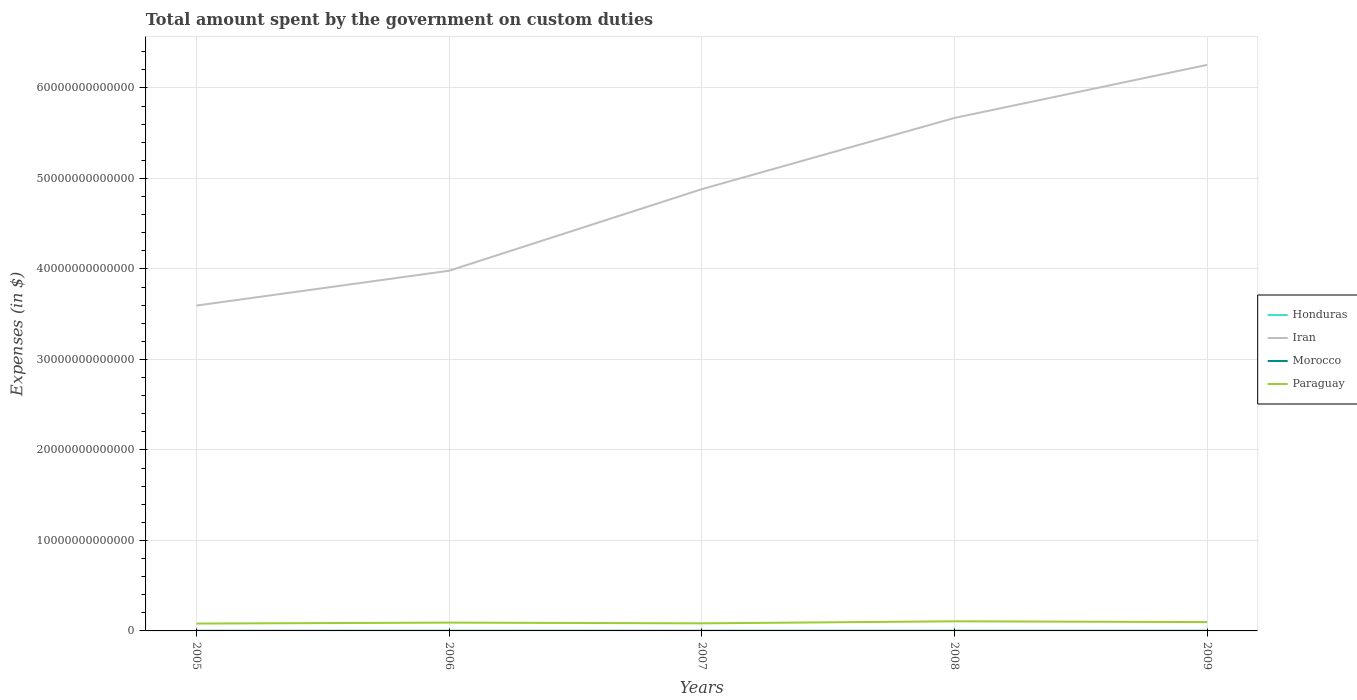Does the line corresponding to Iran intersect with the line corresponding to Morocco?
Your answer should be very brief. No. Is the number of lines equal to the number of legend labels?
Offer a terse response. Yes. Across all years, what is the maximum amount spent on custom duties by the government in Iran?
Provide a short and direct response. 3.60e+13. What is the total amount spent on custom duties by the government in Paraguay in the graph?
Make the answer very short. -1.40e+11. What is the difference between the highest and the second highest amount spent on custom duties by the government in Paraguay?
Your answer should be very brief. 2.49e+11. Is the amount spent on custom duties by the government in Iran strictly greater than the amount spent on custom duties by the government in Honduras over the years?
Your answer should be very brief. No. How many lines are there?
Offer a terse response. 4. What is the difference between two consecutive major ticks on the Y-axis?
Keep it short and to the point. 1.00e+13. Are the values on the major ticks of Y-axis written in scientific E-notation?
Offer a very short reply. No. Where does the legend appear in the graph?
Your answer should be very brief. Center right. How many legend labels are there?
Keep it short and to the point. 4. How are the legend labels stacked?
Give a very brief answer. Vertical. What is the title of the graph?
Give a very brief answer. Total amount spent by the government on custom duties. Does "Cyprus" appear as one of the legend labels in the graph?
Make the answer very short. No. What is the label or title of the Y-axis?
Your answer should be very brief. Expenses (in $). What is the Expenses (in $) in Honduras in 2005?
Ensure brevity in your answer.  2.18e+09. What is the Expenses (in $) of Iran in 2005?
Your answer should be very brief. 3.60e+13. What is the Expenses (in $) of Morocco in 2005?
Offer a terse response. 1.24e+1. What is the Expenses (in $) in Paraguay in 2005?
Your response must be concise. 8.13e+11. What is the Expenses (in $) in Honduras in 2006?
Keep it short and to the point. 2.35e+09. What is the Expenses (in $) in Iran in 2006?
Offer a terse response. 3.98e+13. What is the Expenses (in $) in Morocco in 2006?
Provide a short and direct response. 1.23e+1. What is the Expenses (in $) in Paraguay in 2006?
Ensure brevity in your answer.  9.18e+11. What is the Expenses (in $) of Honduras in 2007?
Make the answer very short. 2.88e+09. What is the Expenses (in $) in Iran in 2007?
Offer a terse response. 4.88e+13. What is the Expenses (in $) in Morocco in 2007?
Give a very brief answer. 1.34e+1. What is the Expenses (in $) of Paraguay in 2007?
Provide a succinct answer. 8.38e+11. What is the Expenses (in $) of Honduras in 2008?
Make the answer very short. 2.98e+09. What is the Expenses (in $) of Iran in 2008?
Offer a terse response. 5.67e+13. What is the Expenses (in $) of Morocco in 2008?
Give a very brief answer. 1.37e+1. What is the Expenses (in $) of Paraguay in 2008?
Keep it short and to the point. 1.06e+12. What is the Expenses (in $) of Honduras in 2009?
Keep it short and to the point. 2.07e+09. What is the Expenses (in $) in Iran in 2009?
Your answer should be very brief. 6.26e+13. What is the Expenses (in $) in Morocco in 2009?
Offer a terse response. 1.18e+1. What is the Expenses (in $) of Paraguay in 2009?
Your answer should be compact. 9.77e+11. Across all years, what is the maximum Expenses (in $) in Honduras?
Your answer should be compact. 2.98e+09. Across all years, what is the maximum Expenses (in $) in Iran?
Give a very brief answer. 6.26e+13. Across all years, what is the maximum Expenses (in $) of Morocco?
Keep it short and to the point. 1.37e+1. Across all years, what is the maximum Expenses (in $) in Paraguay?
Your answer should be very brief. 1.06e+12. Across all years, what is the minimum Expenses (in $) in Honduras?
Ensure brevity in your answer.  2.07e+09. Across all years, what is the minimum Expenses (in $) in Iran?
Provide a short and direct response. 3.60e+13. Across all years, what is the minimum Expenses (in $) in Morocco?
Your response must be concise. 1.18e+1. Across all years, what is the minimum Expenses (in $) of Paraguay?
Offer a very short reply. 8.13e+11. What is the total Expenses (in $) of Honduras in the graph?
Keep it short and to the point. 1.25e+1. What is the total Expenses (in $) of Iran in the graph?
Provide a succinct answer. 2.44e+14. What is the total Expenses (in $) of Morocco in the graph?
Your answer should be very brief. 6.37e+1. What is the total Expenses (in $) in Paraguay in the graph?
Give a very brief answer. 4.61e+12. What is the difference between the Expenses (in $) of Honduras in 2005 and that in 2006?
Ensure brevity in your answer.  -1.74e+08. What is the difference between the Expenses (in $) in Iran in 2005 and that in 2006?
Your answer should be compact. -3.85e+12. What is the difference between the Expenses (in $) in Morocco in 2005 and that in 2006?
Keep it short and to the point. 6.50e+07. What is the difference between the Expenses (in $) in Paraguay in 2005 and that in 2006?
Give a very brief answer. -1.06e+11. What is the difference between the Expenses (in $) in Honduras in 2005 and that in 2007?
Ensure brevity in your answer.  -7.00e+08. What is the difference between the Expenses (in $) of Iran in 2005 and that in 2007?
Keep it short and to the point. -1.29e+13. What is the difference between the Expenses (in $) of Morocco in 2005 and that in 2007?
Offer a terse response. -1.01e+09. What is the difference between the Expenses (in $) in Paraguay in 2005 and that in 2007?
Your answer should be very brief. -2.49e+1. What is the difference between the Expenses (in $) in Honduras in 2005 and that in 2008?
Provide a succinct answer. -7.97e+08. What is the difference between the Expenses (in $) in Iran in 2005 and that in 2008?
Keep it short and to the point. -2.07e+13. What is the difference between the Expenses (in $) of Morocco in 2005 and that in 2008?
Your answer should be very brief. -1.30e+09. What is the difference between the Expenses (in $) in Paraguay in 2005 and that in 2008?
Provide a succinct answer. -2.49e+11. What is the difference between the Expenses (in $) of Honduras in 2005 and that in 2009?
Ensure brevity in your answer.  1.13e+08. What is the difference between the Expenses (in $) in Iran in 2005 and that in 2009?
Provide a succinct answer. -2.66e+13. What is the difference between the Expenses (in $) in Morocco in 2005 and that in 2009?
Your response must be concise. 5.79e+08. What is the difference between the Expenses (in $) of Paraguay in 2005 and that in 2009?
Ensure brevity in your answer.  -1.65e+11. What is the difference between the Expenses (in $) in Honduras in 2006 and that in 2007?
Keep it short and to the point. -5.26e+08. What is the difference between the Expenses (in $) of Iran in 2006 and that in 2007?
Provide a succinct answer. -9.01e+12. What is the difference between the Expenses (in $) in Morocco in 2006 and that in 2007?
Your answer should be very brief. -1.07e+09. What is the difference between the Expenses (in $) of Paraguay in 2006 and that in 2007?
Make the answer very short. 8.09e+1. What is the difference between the Expenses (in $) in Honduras in 2006 and that in 2008?
Provide a succinct answer. -6.22e+08. What is the difference between the Expenses (in $) in Iran in 2006 and that in 2008?
Offer a very short reply. -1.69e+13. What is the difference between the Expenses (in $) of Morocco in 2006 and that in 2008?
Your answer should be very brief. -1.36e+09. What is the difference between the Expenses (in $) of Paraguay in 2006 and that in 2008?
Provide a succinct answer. -1.43e+11. What is the difference between the Expenses (in $) of Honduras in 2006 and that in 2009?
Your response must be concise. 2.88e+08. What is the difference between the Expenses (in $) of Iran in 2006 and that in 2009?
Offer a very short reply. -2.27e+13. What is the difference between the Expenses (in $) of Morocco in 2006 and that in 2009?
Ensure brevity in your answer.  5.14e+08. What is the difference between the Expenses (in $) in Paraguay in 2006 and that in 2009?
Your answer should be very brief. -5.89e+1. What is the difference between the Expenses (in $) of Honduras in 2007 and that in 2008?
Make the answer very short. -9.62e+07. What is the difference between the Expenses (in $) in Iran in 2007 and that in 2008?
Keep it short and to the point. -7.87e+12. What is the difference between the Expenses (in $) of Morocco in 2007 and that in 2008?
Your answer should be very brief. -2.91e+08. What is the difference between the Expenses (in $) of Paraguay in 2007 and that in 2008?
Offer a terse response. -2.24e+11. What is the difference between the Expenses (in $) in Honduras in 2007 and that in 2009?
Keep it short and to the point. 8.14e+08. What is the difference between the Expenses (in $) in Iran in 2007 and that in 2009?
Provide a short and direct response. -1.37e+13. What is the difference between the Expenses (in $) in Morocco in 2007 and that in 2009?
Your answer should be very brief. 1.59e+09. What is the difference between the Expenses (in $) of Paraguay in 2007 and that in 2009?
Your answer should be compact. -1.40e+11. What is the difference between the Expenses (in $) in Honduras in 2008 and that in 2009?
Give a very brief answer. 9.10e+08. What is the difference between the Expenses (in $) in Iran in 2008 and that in 2009?
Offer a very short reply. -5.87e+12. What is the difference between the Expenses (in $) of Morocco in 2008 and that in 2009?
Give a very brief answer. 1.88e+09. What is the difference between the Expenses (in $) in Paraguay in 2008 and that in 2009?
Provide a short and direct response. 8.42e+1. What is the difference between the Expenses (in $) in Honduras in 2005 and the Expenses (in $) in Iran in 2006?
Your response must be concise. -3.98e+13. What is the difference between the Expenses (in $) of Honduras in 2005 and the Expenses (in $) of Morocco in 2006?
Your response must be concise. -1.02e+1. What is the difference between the Expenses (in $) of Honduras in 2005 and the Expenses (in $) of Paraguay in 2006?
Give a very brief answer. -9.16e+11. What is the difference between the Expenses (in $) of Iran in 2005 and the Expenses (in $) of Morocco in 2006?
Give a very brief answer. 3.59e+13. What is the difference between the Expenses (in $) in Iran in 2005 and the Expenses (in $) in Paraguay in 2006?
Make the answer very short. 3.50e+13. What is the difference between the Expenses (in $) of Morocco in 2005 and the Expenses (in $) of Paraguay in 2006?
Your answer should be very brief. -9.06e+11. What is the difference between the Expenses (in $) of Honduras in 2005 and the Expenses (in $) of Iran in 2007?
Give a very brief answer. -4.88e+13. What is the difference between the Expenses (in $) in Honduras in 2005 and the Expenses (in $) in Morocco in 2007?
Offer a very short reply. -1.12e+1. What is the difference between the Expenses (in $) in Honduras in 2005 and the Expenses (in $) in Paraguay in 2007?
Offer a terse response. -8.35e+11. What is the difference between the Expenses (in $) in Iran in 2005 and the Expenses (in $) in Morocco in 2007?
Offer a terse response. 3.59e+13. What is the difference between the Expenses (in $) of Iran in 2005 and the Expenses (in $) of Paraguay in 2007?
Ensure brevity in your answer.  3.51e+13. What is the difference between the Expenses (in $) in Morocco in 2005 and the Expenses (in $) in Paraguay in 2007?
Your answer should be compact. -8.25e+11. What is the difference between the Expenses (in $) in Honduras in 2005 and the Expenses (in $) in Iran in 2008?
Offer a very short reply. -5.67e+13. What is the difference between the Expenses (in $) in Honduras in 2005 and the Expenses (in $) in Morocco in 2008?
Provide a short and direct response. -1.15e+1. What is the difference between the Expenses (in $) in Honduras in 2005 and the Expenses (in $) in Paraguay in 2008?
Provide a succinct answer. -1.06e+12. What is the difference between the Expenses (in $) of Iran in 2005 and the Expenses (in $) of Morocco in 2008?
Offer a very short reply. 3.59e+13. What is the difference between the Expenses (in $) of Iran in 2005 and the Expenses (in $) of Paraguay in 2008?
Provide a succinct answer. 3.49e+13. What is the difference between the Expenses (in $) of Morocco in 2005 and the Expenses (in $) of Paraguay in 2008?
Ensure brevity in your answer.  -1.05e+12. What is the difference between the Expenses (in $) of Honduras in 2005 and the Expenses (in $) of Iran in 2009?
Your answer should be compact. -6.26e+13. What is the difference between the Expenses (in $) in Honduras in 2005 and the Expenses (in $) in Morocco in 2009?
Offer a very short reply. -9.65e+09. What is the difference between the Expenses (in $) of Honduras in 2005 and the Expenses (in $) of Paraguay in 2009?
Your response must be concise. -9.75e+11. What is the difference between the Expenses (in $) of Iran in 2005 and the Expenses (in $) of Morocco in 2009?
Offer a terse response. 3.59e+13. What is the difference between the Expenses (in $) in Iran in 2005 and the Expenses (in $) in Paraguay in 2009?
Offer a terse response. 3.50e+13. What is the difference between the Expenses (in $) of Morocco in 2005 and the Expenses (in $) of Paraguay in 2009?
Ensure brevity in your answer.  -9.65e+11. What is the difference between the Expenses (in $) in Honduras in 2006 and the Expenses (in $) in Iran in 2007?
Offer a terse response. -4.88e+13. What is the difference between the Expenses (in $) in Honduras in 2006 and the Expenses (in $) in Morocco in 2007?
Your answer should be compact. -1.11e+1. What is the difference between the Expenses (in $) in Honduras in 2006 and the Expenses (in $) in Paraguay in 2007?
Your answer should be compact. -8.35e+11. What is the difference between the Expenses (in $) in Iran in 2006 and the Expenses (in $) in Morocco in 2007?
Offer a terse response. 3.98e+13. What is the difference between the Expenses (in $) of Iran in 2006 and the Expenses (in $) of Paraguay in 2007?
Your answer should be compact. 3.90e+13. What is the difference between the Expenses (in $) of Morocco in 2006 and the Expenses (in $) of Paraguay in 2007?
Keep it short and to the point. -8.25e+11. What is the difference between the Expenses (in $) of Honduras in 2006 and the Expenses (in $) of Iran in 2008?
Offer a terse response. -5.67e+13. What is the difference between the Expenses (in $) in Honduras in 2006 and the Expenses (in $) in Morocco in 2008?
Your answer should be very brief. -1.14e+1. What is the difference between the Expenses (in $) in Honduras in 2006 and the Expenses (in $) in Paraguay in 2008?
Your response must be concise. -1.06e+12. What is the difference between the Expenses (in $) of Iran in 2006 and the Expenses (in $) of Morocco in 2008?
Ensure brevity in your answer.  3.98e+13. What is the difference between the Expenses (in $) of Iran in 2006 and the Expenses (in $) of Paraguay in 2008?
Your answer should be compact. 3.87e+13. What is the difference between the Expenses (in $) of Morocco in 2006 and the Expenses (in $) of Paraguay in 2008?
Offer a terse response. -1.05e+12. What is the difference between the Expenses (in $) of Honduras in 2006 and the Expenses (in $) of Iran in 2009?
Provide a succinct answer. -6.26e+13. What is the difference between the Expenses (in $) in Honduras in 2006 and the Expenses (in $) in Morocco in 2009?
Give a very brief answer. -9.48e+09. What is the difference between the Expenses (in $) of Honduras in 2006 and the Expenses (in $) of Paraguay in 2009?
Offer a very short reply. -9.75e+11. What is the difference between the Expenses (in $) of Iran in 2006 and the Expenses (in $) of Morocco in 2009?
Your response must be concise. 3.98e+13. What is the difference between the Expenses (in $) of Iran in 2006 and the Expenses (in $) of Paraguay in 2009?
Give a very brief answer. 3.88e+13. What is the difference between the Expenses (in $) of Morocco in 2006 and the Expenses (in $) of Paraguay in 2009?
Provide a succinct answer. -9.65e+11. What is the difference between the Expenses (in $) in Honduras in 2007 and the Expenses (in $) in Iran in 2008?
Keep it short and to the point. -5.67e+13. What is the difference between the Expenses (in $) in Honduras in 2007 and the Expenses (in $) in Morocco in 2008?
Give a very brief answer. -1.08e+1. What is the difference between the Expenses (in $) in Honduras in 2007 and the Expenses (in $) in Paraguay in 2008?
Offer a terse response. -1.06e+12. What is the difference between the Expenses (in $) of Iran in 2007 and the Expenses (in $) of Morocco in 2008?
Offer a very short reply. 4.88e+13. What is the difference between the Expenses (in $) of Iran in 2007 and the Expenses (in $) of Paraguay in 2008?
Your answer should be very brief. 4.78e+13. What is the difference between the Expenses (in $) in Morocco in 2007 and the Expenses (in $) in Paraguay in 2008?
Your answer should be very brief. -1.05e+12. What is the difference between the Expenses (in $) in Honduras in 2007 and the Expenses (in $) in Iran in 2009?
Ensure brevity in your answer.  -6.26e+13. What is the difference between the Expenses (in $) of Honduras in 2007 and the Expenses (in $) of Morocco in 2009?
Your response must be concise. -8.95e+09. What is the difference between the Expenses (in $) of Honduras in 2007 and the Expenses (in $) of Paraguay in 2009?
Your response must be concise. -9.75e+11. What is the difference between the Expenses (in $) in Iran in 2007 and the Expenses (in $) in Morocco in 2009?
Provide a succinct answer. 4.88e+13. What is the difference between the Expenses (in $) in Iran in 2007 and the Expenses (in $) in Paraguay in 2009?
Your response must be concise. 4.78e+13. What is the difference between the Expenses (in $) of Morocco in 2007 and the Expenses (in $) of Paraguay in 2009?
Your answer should be compact. -9.64e+11. What is the difference between the Expenses (in $) in Honduras in 2008 and the Expenses (in $) in Iran in 2009?
Ensure brevity in your answer.  -6.26e+13. What is the difference between the Expenses (in $) in Honduras in 2008 and the Expenses (in $) in Morocco in 2009?
Ensure brevity in your answer.  -8.85e+09. What is the difference between the Expenses (in $) in Honduras in 2008 and the Expenses (in $) in Paraguay in 2009?
Make the answer very short. -9.74e+11. What is the difference between the Expenses (in $) of Iran in 2008 and the Expenses (in $) of Morocco in 2009?
Provide a short and direct response. 5.67e+13. What is the difference between the Expenses (in $) in Iran in 2008 and the Expenses (in $) in Paraguay in 2009?
Provide a succinct answer. 5.57e+13. What is the difference between the Expenses (in $) of Morocco in 2008 and the Expenses (in $) of Paraguay in 2009?
Give a very brief answer. -9.64e+11. What is the average Expenses (in $) of Honduras per year?
Ensure brevity in your answer.  2.49e+09. What is the average Expenses (in $) of Iran per year?
Provide a short and direct response. 4.88e+13. What is the average Expenses (in $) in Morocco per year?
Your response must be concise. 1.27e+1. What is the average Expenses (in $) of Paraguay per year?
Give a very brief answer. 9.22e+11. In the year 2005, what is the difference between the Expenses (in $) of Honduras and Expenses (in $) of Iran?
Ensure brevity in your answer.  -3.60e+13. In the year 2005, what is the difference between the Expenses (in $) of Honduras and Expenses (in $) of Morocco?
Offer a very short reply. -1.02e+1. In the year 2005, what is the difference between the Expenses (in $) in Honduras and Expenses (in $) in Paraguay?
Ensure brevity in your answer.  -8.11e+11. In the year 2005, what is the difference between the Expenses (in $) in Iran and Expenses (in $) in Morocco?
Give a very brief answer. 3.59e+13. In the year 2005, what is the difference between the Expenses (in $) in Iran and Expenses (in $) in Paraguay?
Your response must be concise. 3.51e+13. In the year 2005, what is the difference between the Expenses (in $) of Morocco and Expenses (in $) of Paraguay?
Give a very brief answer. -8.00e+11. In the year 2006, what is the difference between the Expenses (in $) of Honduras and Expenses (in $) of Iran?
Offer a very short reply. -3.98e+13. In the year 2006, what is the difference between the Expenses (in $) in Honduras and Expenses (in $) in Morocco?
Offer a terse response. -9.99e+09. In the year 2006, what is the difference between the Expenses (in $) in Honduras and Expenses (in $) in Paraguay?
Keep it short and to the point. -9.16e+11. In the year 2006, what is the difference between the Expenses (in $) of Iran and Expenses (in $) of Morocco?
Provide a short and direct response. 3.98e+13. In the year 2006, what is the difference between the Expenses (in $) of Iran and Expenses (in $) of Paraguay?
Ensure brevity in your answer.  3.89e+13. In the year 2006, what is the difference between the Expenses (in $) in Morocco and Expenses (in $) in Paraguay?
Give a very brief answer. -9.06e+11. In the year 2007, what is the difference between the Expenses (in $) in Honduras and Expenses (in $) in Iran?
Keep it short and to the point. -4.88e+13. In the year 2007, what is the difference between the Expenses (in $) of Honduras and Expenses (in $) of Morocco?
Provide a succinct answer. -1.05e+1. In the year 2007, what is the difference between the Expenses (in $) of Honduras and Expenses (in $) of Paraguay?
Your answer should be compact. -8.35e+11. In the year 2007, what is the difference between the Expenses (in $) in Iran and Expenses (in $) in Morocco?
Provide a short and direct response. 4.88e+13. In the year 2007, what is the difference between the Expenses (in $) of Iran and Expenses (in $) of Paraguay?
Your answer should be compact. 4.80e+13. In the year 2007, what is the difference between the Expenses (in $) of Morocco and Expenses (in $) of Paraguay?
Give a very brief answer. -8.24e+11. In the year 2008, what is the difference between the Expenses (in $) in Honduras and Expenses (in $) in Iran?
Offer a terse response. -5.67e+13. In the year 2008, what is the difference between the Expenses (in $) in Honduras and Expenses (in $) in Morocco?
Offer a terse response. -1.07e+1. In the year 2008, what is the difference between the Expenses (in $) of Honduras and Expenses (in $) of Paraguay?
Provide a short and direct response. -1.06e+12. In the year 2008, what is the difference between the Expenses (in $) in Iran and Expenses (in $) in Morocco?
Provide a succinct answer. 5.67e+13. In the year 2008, what is the difference between the Expenses (in $) of Iran and Expenses (in $) of Paraguay?
Offer a very short reply. 5.56e+13. In the year 2008, what is the difference between the Expenses (in $) in Morocco and Expenses (in $) in Paraguay?
Provide a succinct answer. -1.05e+12. In the year 2009, what is the difference between the Expenses (in $) in Honduras and Expenses (in $) in Iran?
Offer a terse response. -6.26e+13. In the year 2009, what is the difference between the Expenses (in $) in Honduras and Expenses (in $) in Morocco?
Give a very brief answer. -9.76e+09. In the year 2009, what is the difference between the Expenses (in $) in Honduras and Expenses (in $) in Paraguay?
Keep it short and to the point. -9.75e+11. In the year 2009, what is the difference between the Expenses (in $) in Iran and Expenses (in $) in Morocco?
Provide a succinct answer. 6.25e+13. In the year 2009, what is the difference between the Expenses (in $) in Iran and Expenses (in $) in Paraguay?
Give a very brief answer. 6.16e+13. In the year 2009, what is the difference between the Expenses (in $) in Morocco and Expenses (in $) in Paraguay?
Your answer should be very brief. -9.66e+11. What is the ratio of the Expenses (in $) of Honduras in 2005 to that in 2006?
Provide a succinct answer. 0.93. What is the ratio of the Expenses (in $) of Iran in 2005 to that in 2006?
Give a very brief answer. 0.9. What is the ratio of the Expenses (in $) of Paraguay in 2005 to that in 2006?
Your answer should be compact. 0.88. What is the ratio of the Expenses (in $) of Honduras in 2005 to that in 2007?
Offer a very short reply. 0.76. What is the ratio of the Expenses (in $) in Iran in 2005 to that in 2007?
Offer a terse response. 0.74. What is the ratio of the Expenses (in $) in Morocco in 2005 to that in 2007?
Provide a short and direct response. 0.93. What is the ratio of the Expenses (in $) in Paraguay in 2005 to that in 2007?
Provide a succinct answer. 0.97. What is the ratio of the Expenses (in $) in Honduras in 2005 to that in 2008?
Your response must be concise. 0.73. What is the ratio of the Expenses (in $) in Iran in 2005 to that in 2008?
Provide a short and direct response. 0.63. What is the ratio of the Expenses (in $) in Morocco in 2005 to that in 2008?
Keep it short and to the point. 0.91. What is the ratio of the Expenses (in $) in Paraguay in 2005 to that in 2008?
Offer a very short reply. 0.77. What is the ratio of the Expenses (in $) of Honduras in 2005 to that in 2009?
Your response must be concise. 1.05. What is the ratio of the Expenses (in $) of Iran in 2005 to that in 2009?
Provide a succinct answer. 0.57. What is the ratio of the Expenses (in $) in Morocco in 2005 to that in 2009?
Make the answer very short. 1.05. What is the ratio of the Expenses (in $) in Paraguay in 2005 to that in 2009?
Your response must be concise. 0.83. What is the ratio of the Expenses (in $) of Honduras in 2006 to that in 2007?
Offer a terse response. 0.82. What is the ratio of the Expenses (in $) of Iran in 2006 to that in 2007?
Your answer should be compact. 0.82. What is the ratio of the Expenses (in $) in Morocco in 2006 to that in 2007?
Your response must be concise. 0.92. What is the ratio of the Expenses (in $) of Paraguay in 2006 to that in 2007?
Keep it short and to the point. 1.1. What is the ratio of the Expenses (in $) in Honduras in 2006 to that in 2008?
Provide a short and direct response. 0.79. What is the ratio of the Expenses (in $) of Iran in 2006 to that in 2008?
Provide a succinct answer. 0.7. What is the ratio of the Expenses (in $) of Morocco in 2006 to that in 2008?
Make the answer very short. 0.9. What is the ratio of the Expenses (in $) in Paraguay in 2006 to that in 2008?
Your answer should be compact. 0.87. What is the ratio of the Expenses (in $) of Honduras in 2006 to that in 2009?
Provide a succinct answer. 1.14. What is the ratio of the Expenses (in $) of Iran in 2006 to that in 2009?
Give a very brief answer. 0.64. What is the ratio of the Expenses (in $) of Morocco in 2006 to that in 2009?
Keep it short and to the point. 1.04. What is the ratio of the Expenses (in $) of Paraguay in 2006 to that in 2009?
Give a very brief answer. 0.94. What is the ratio of the Expenses (in $) in Iran in 2007 to that in 2008?
Offer a very short reply. 0.86. What is the ratio of the Expenses (in $) of Morocco in 2007 to that in 2008?
Your answer should be compact. 0.98. What is the ratio of the Expenses (in $) of Paraguay in 2007 to that in 2008?
Keep it short and to the point. 0.79. What is the ratio of the Expenses (in $) in Honduras in 2007 to that in 2009?
Offer a terse response. 1.39. What is the ratio of the Expenses (in $) of Iran in 2007 to that in 2009?
Your answer should be very brief. 0.78. What is the ratio of the Expenses (in $) of Morocco in 2007 to that in 2009?
Your answer should be very brief. 1.13. What is the ratio of the Expenses (in $) of Paraguay in 2007 to that in 2009?
Your answer should be very brief. 0.86. What is the ratio of the Expenses (in $) of Honduras in 2008 to that in 2009?
Your answer should be compact. 1.44. What is the ratio of the Expenses (in $) in Iran in 2008 to that in 2009?
Keep it short and to the point. 0.91. What is the ratio of the Expenses (in $) of Morocco in 2008 to that in 2009?
Keep it short and to the point. 1.16. What is the ratio of the Expenses (in $) of Paraguay in 2008 to that in 2009?
Your answer should be compact. 1.09. What is the difference between the highest and the second highest Expenses (in $) of Honduras?
Keep it short and to the point. 9.62e+07. What is the difference between the highest and the second highest Expenses (in $) of Iran?
Make the answer very short. 5.87e+12. What is the difference between the highest and the second highest Expenses (in $) in Morocco?
Make the answer very short. 2.91e+08. What is the difference between the highest and the second highest Expenses (in $) in Paraguay?
Give a very brief answer. 8.42e+1. What is the difference between the highest and the lowest Expenses (in $) in Honduras?
Make the answer very short. 9.10e+08. What is the difference between the highest and the lowest Expenses (in $) of Iran?
Provide a succinct answer. 2.66e+13. What is the difference between the highest and the lowest Expenses (in $) in Morocco?
Offer a very short reply. 1.88e+09. What is the difference between the highest and the lowest Expenses (in $) in Paraguay?
Provide a succinct answer. 2.49e+11. 